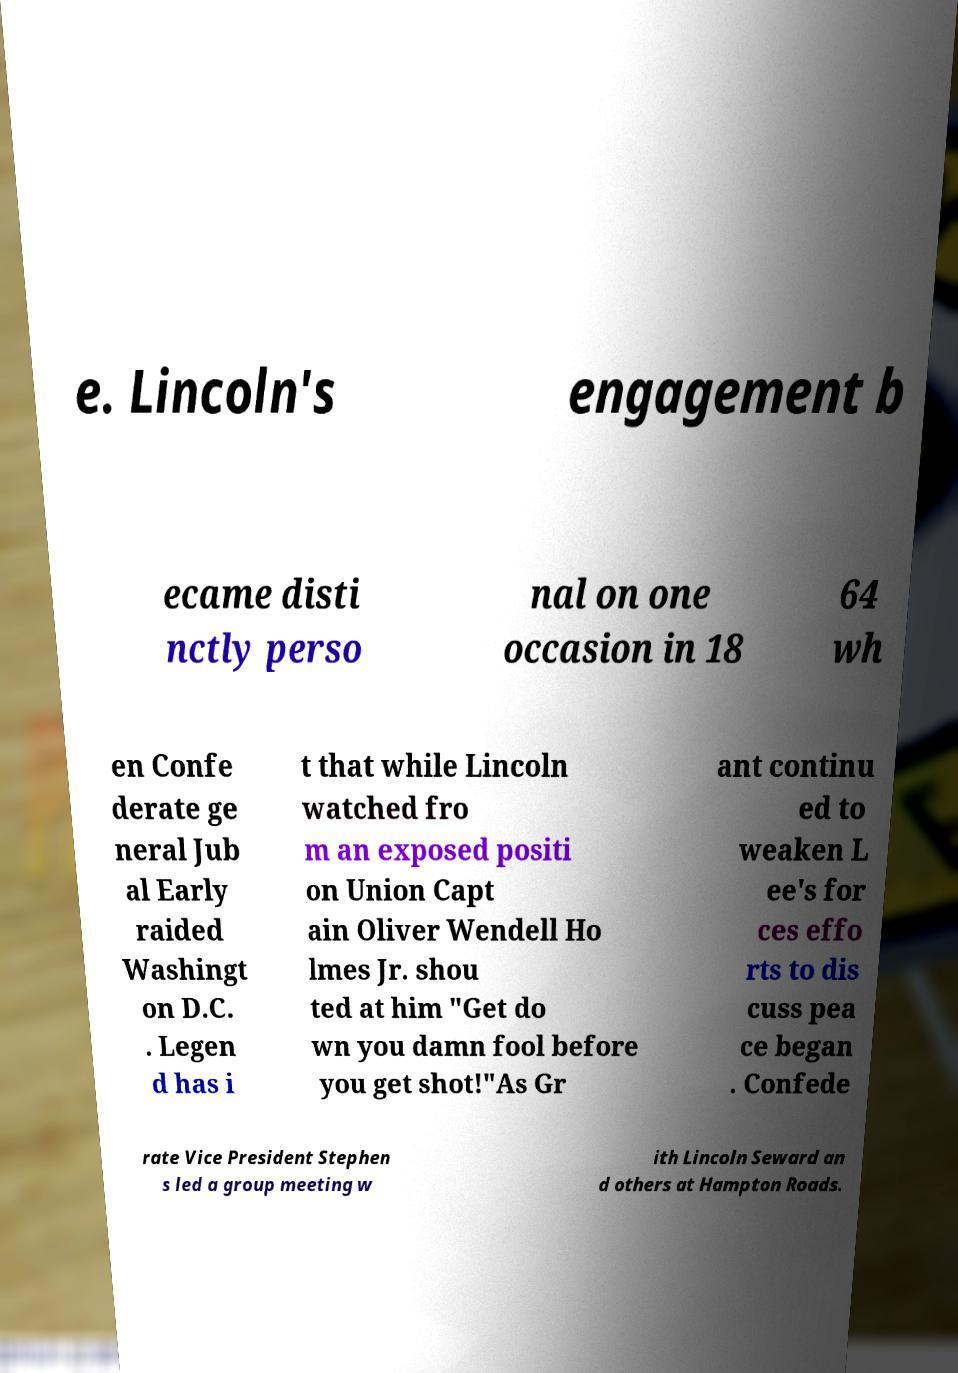Please identify and transcribe the text found in this image. e. Lincoln's engagement b ecame disti nctly perso nal on one occasion in 18 64 wh en Confe derate ge neral Jub al Early raided Washingt on D.C. . Legen d has i t that while Lincoln watched fro m an exposed positi on Union Capt ain Oliver Wendell Ho lmes Jr. shou ted at him "Get do wn you damn fool before you get shot!"As Gr ant continu ed to weaken L ee's for ces effo rts to dis cuss pea ce began . Confede rate Vice President Stephen s led a group meeting w ith Lincoln Seward an d others at Hampton Roads. 